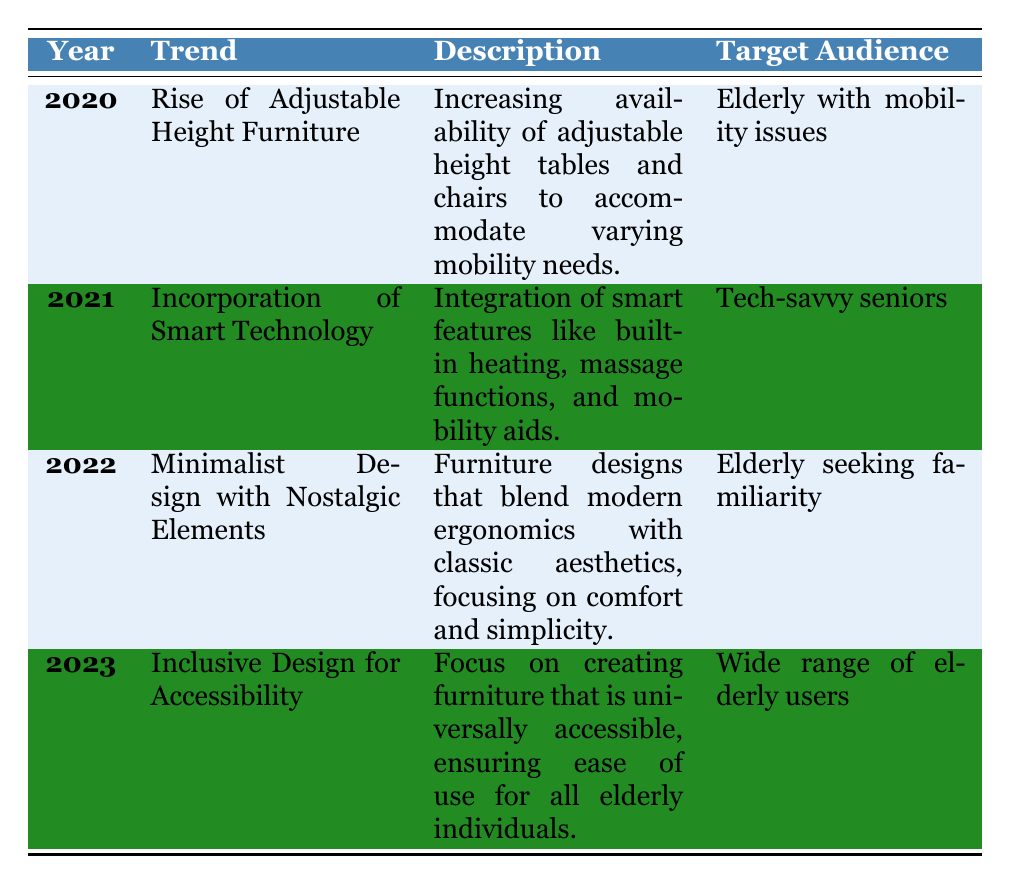What was the trend in ergonomic furniture for the elderly in 2021? The table shows that in 2021, the trend was the "Incorporation of Smart Technology," which included features like built-in heating and mobility aids.
Answer: Incorporation of Smart Technology Which year saw the introduction of Minimalist Design with Nostalgic Elements? Looking at the table, it indicates that Minimalist Design with Nostalgic Elements was introduced in 2022.
Answer: 2022 Is the target audience the same for the trends in 2020 and 2023? In 2020, the target audience was the elderly with mobility issues, while in 2023, it expanded to a wide range of elderly users, thus they are not the same.
Answer: No What materials were commonly used in ergonomic furniture trends from 2020 to 2022? The relevant materials from the years 2020, 2021, and 2022 include recycled wood and eco-friendly metals in 2020, and memory foam and smart textiles in 2021, along with solid oak and soft fabrics in 2022.
Answer: Recycled wood, eco-friendly metals, memory foam, smart textiles, solid oak, soft fabrics Which trend focused on accessibility for all elderly individuals? The table shows that the trend focusing on accessibility for all elderly individuals is "Inclusive Design for Accessibility," which was noted in 2023.
Answer: Inclusive Design for Accessibility How many different trends are outlined in the table for the years 2020 to 2023? The table contains trends listed for each year from 2020 through 2023, totaling four distinct trends.
Answer: 4 Did the target audience for ergonomic furniture trends change from 2020 to 2023? Yes, the target audience evolved from elderly with mobility issues in 2020 to a more inclusive audience in 2023, which includes a wide range of elderly users.
Answer: Yes What brands were pivotal in the 2022 trend and what was that trend focused on? The brands pivotal in the 2022 trend, which was Minimalist Design with Nostalgic Elements, included Muuto, Hay, and Scanteak.
Answer: Muuto, Hay, Scanteak; Minimalist Design with Nostalgic Elements Which years emphasized eco-friendly materials in ergonomic furniture? The years 2020 and 2021 emphasized eco-friendly materials, specifically mentioning recycled wood and eco-friendly metals in 2020 and memory foam and smart textiles in 2021.
Answer: 2020 and 2021 Which trend from the table would likely appeal to the largest demographic within the elderly population? The "Inclusive Design for Accessibility" trend from 2023 is likely to appeal to the largest demographic as it targets a wide range of elderly users.
Answer: Inclusive Design for Accessibility 